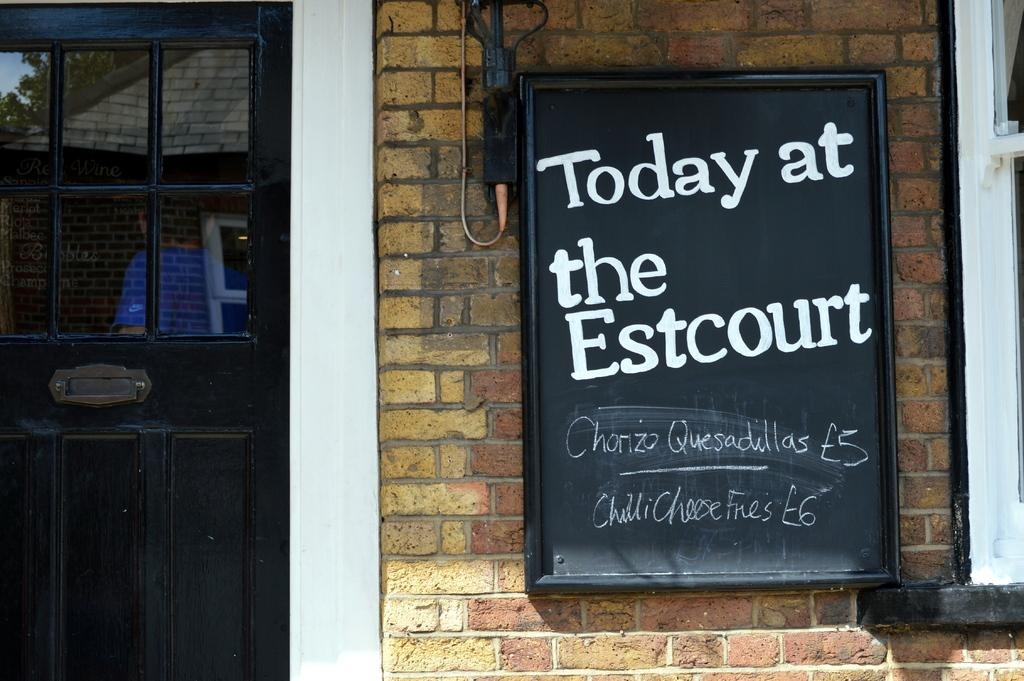What color is the door in the image? The door in the image is black. What is located on a wall in the image? There is a black board on a wall in the image. What can be seen on the black board? There is writing on the black board. What flavor of ice cream is being discussed on the black board? There is no mention of ice cream or any discussion on the black board in the image. Can you see any insects on the black board? There are no insects visible on the black board in the image. 